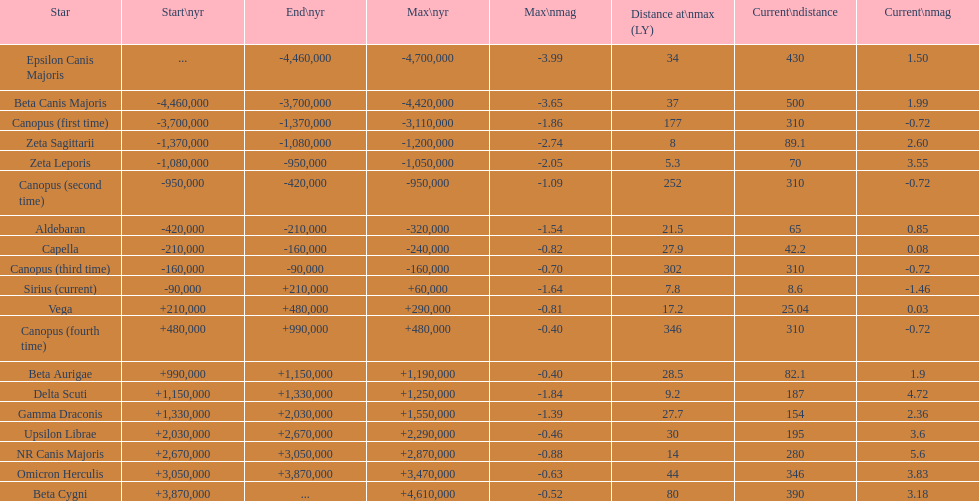What is the difference in the nearest current distance and farthest current distance? 491.4. 